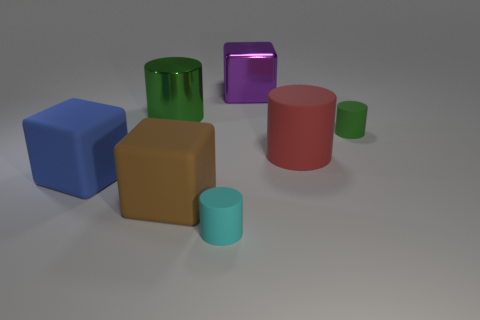Add 1 small cyan metallic blocks. How many objects exist? 8 Subtract all cylinders. How many objects are left? 3 Subtract 0 gray spheres. How many objects are left? 7 Subtract all big brown cubes. Subtract all big things. How many objects are left? 1 Add 7 rubber blocks. How many rubber blocks are left? 9 Add 3 green cylinders. How many green cylinders exist? 5 